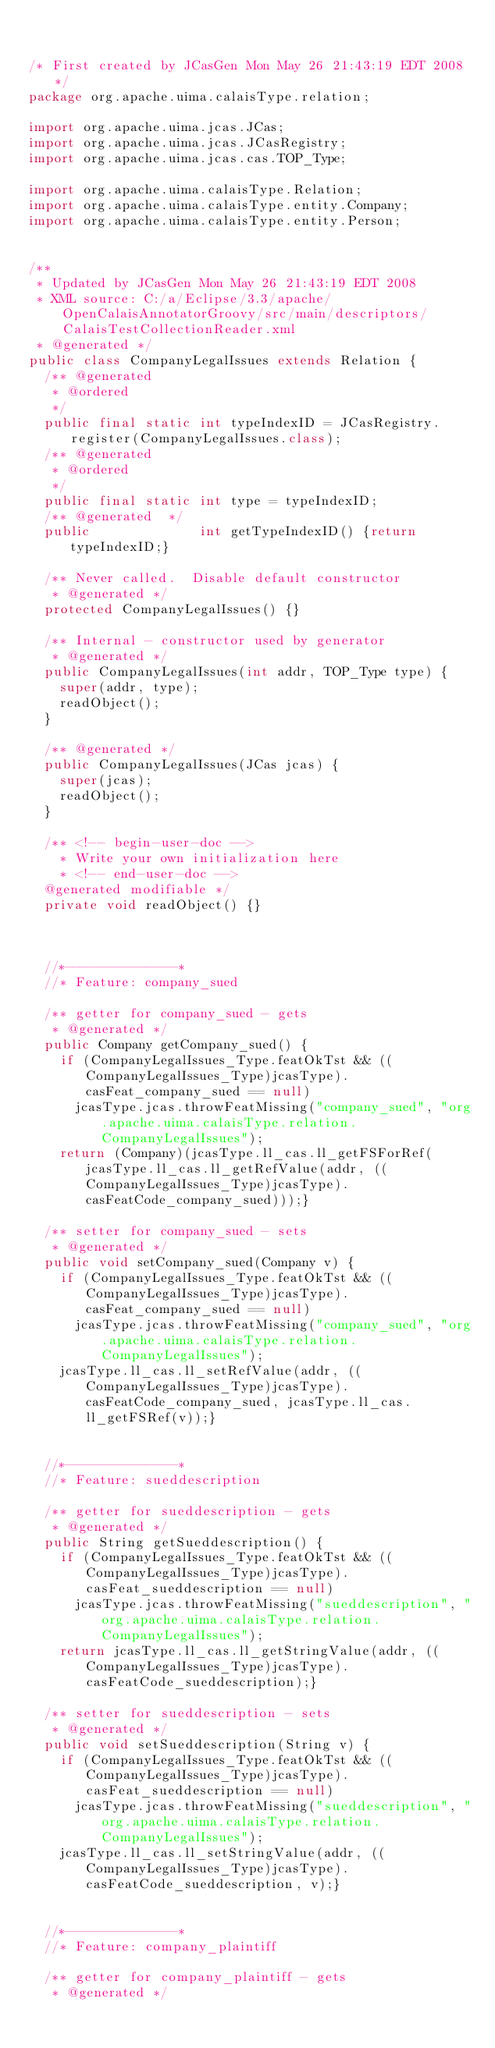Convert code to text. <code><loc_0><loc_0><loc_500><loc_500><_Java_>

/* First created by JCasGen Mon May 26 21:43:19 EDT 2008 */
package org.apache.uima.calaisType.relation;

import org.apache.uima.jcas.JCas; 
import org.apache.uima.jcas.JCasRegistry;
import org.apache.uima.jcas.cas.TOP_Type;

import org.apache.uima.calaisType.Relation;
import org.apache.uima.calaisType.entity.Company;
import org.apache.uima.calaisType.entity.Person;


/** 
 * Updated by JCasGen Mon May 26 21:43:19 EDT 2008
 * XML source: C:/a/Eclipse/3.3/apache/OpenCalaisAnnotatorGroovy/src/main/descriptors/CalaisTestCollectionReader.xml
 * @generated */
public class CompanyLegalIssues extends Relation {
  /** @generated
   * @ordered 
   */
  public final static int typeIndexID = JCasRegistry.register(CompanyLegalIssues.class);
  /** @generated
   * @ordered 
   */
  public final static int type = typeIndexID;
  /** @generated  */
  public              int getTypeIndexID() {return typeIndexID;}
 
  /** Never called.  Disable default constructor
   * @generated */
  protected CompanyLegalIssues() {}
    
  /** Internal - constructor used by generator 
   * @generated */
  public CompanyLegalIssues(int addr, TOP_Type type) {
    super(addr, type);
    readObject();
  }
  
  /** @generated */
  public CompanyLegalIssues(JCas jcas) {
    super(jcas);
    readObject();   
  } 

  /** <!-- begin-user-doc -->
    * Write your own initialization here
    * <!-- end-user-doc -->
  @generated modifiable */
  private void readObject() {}
     
 
    
  //*--------------*
  //* Feature: company_sued

  /** getter for company_sued - gets 
   * @generated */
  public Company getCompany_sued() {
    if (CompanyLegalIssues_Type.featOkTst && ((CompanyLegalIssues_Type)jcasType).casFeat_company_sued == null)
      jcasType.jcas.throwFeatMissing("company_sued", "org.apache.uima.calaisType.relation.CompanyLegalIssues");
    return (Company)(jcasType.ll_cas.ll_getFSForRef(jcasType.ll_cas.ll_getRefValue(addr, ((CompanyLegalIssues_Type)jcasType).casFeatCode_company_sued)));}
    
  /** setter for company_sued - sets  
   * @generated */
  public void setCompany_sued(Company v) {
    if (CompanyLegalIssues_Type.featOkTst && ((CompanyLegalIssues_Type)jcasType).casFeat_company_sued == null)
      jcasType.jcas.throwFeatMissing("company_sued", "org.apache.uima.calaisType.relation.CompanyLegalIssues");
    jcasType.ll_cas.ll_setRefValue(addr, ((CompanyLegalIssues_Type)jcasType).casFeatCode_company_sued, jcasType.ll_cas.ll_getFSRef(v));}    
   
    
  //*--------------*
  //* Feature: sueddescription

  /** getter for sueddescription - gets 
   * @generated */
  public String getSueddescription() {
    if (CompanyLegalIssues_Type.featOkTst && ((CompanyLegalIssues_Type)jcasType).casFeat_sueddescription == null)
      jcasType.jcas.throwFeatMissing("sueddescription", "org.apache.uima.calaisType.relation.CompanyLegalIssues");
    return jcasType.ll_cas.ll_getStringValue(addr, ((CompanyLegalIssues_Type)jcasType).casFeatCode_sueddescription);}
    
  /** setter for sueddescription - sets  
   * @generated */
  public void setSueddescription(String v) {
    if (CompanyLegalIssues_Type.featOkTst && ((CompanyLegalIssues_Type)jcasType).casFeat_sueddescription == null)
      jcasType.jcas.throwFeatMissing("sueddescription", "org.apache.uima.calaisType.relation.CompanyLegalIssues");
    jcasType.ll_cas.ll_setStringValue(addr, ((CompanyLegalIssues_Type)jcasType).casFeatCode_sueddescription, v);}    
   
    
  //*--------------*
  //* Feature: company_plaintiff

  /** getter for company_plaintiff - gets 
   * @generated */</code> 